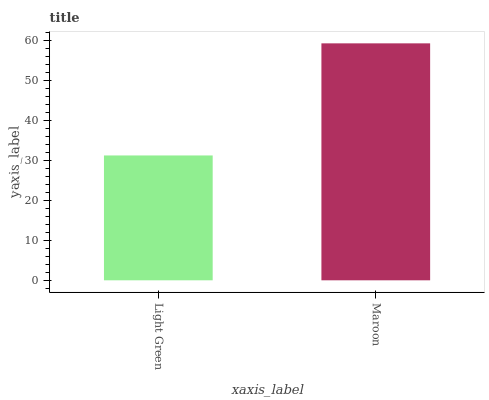Is Light Green the minimum?
Answer yes or no. Yes. Is Maroon the maximum?
Answer yes or no. Yes. Is Maroon the minimum?
Answer yes or no. No. Is Maroon greater than Light Green?
Answer yes or no. Yes. Is Light Green less than Maroon?
Answer yes or no. Yes. Is Light Green greater than Maroon?
Answer yes or no. No. Is Maroon less than Light Green?
Answer yes or no. No. Is Maroon the high median?
Answer yes or no. Yes. Is Light Green the low median?
Answer yes or no. Yes. Is Light Green the high median?
Answer yes or no. No. Is Maroon the low median?
Answer yes or no. No. 